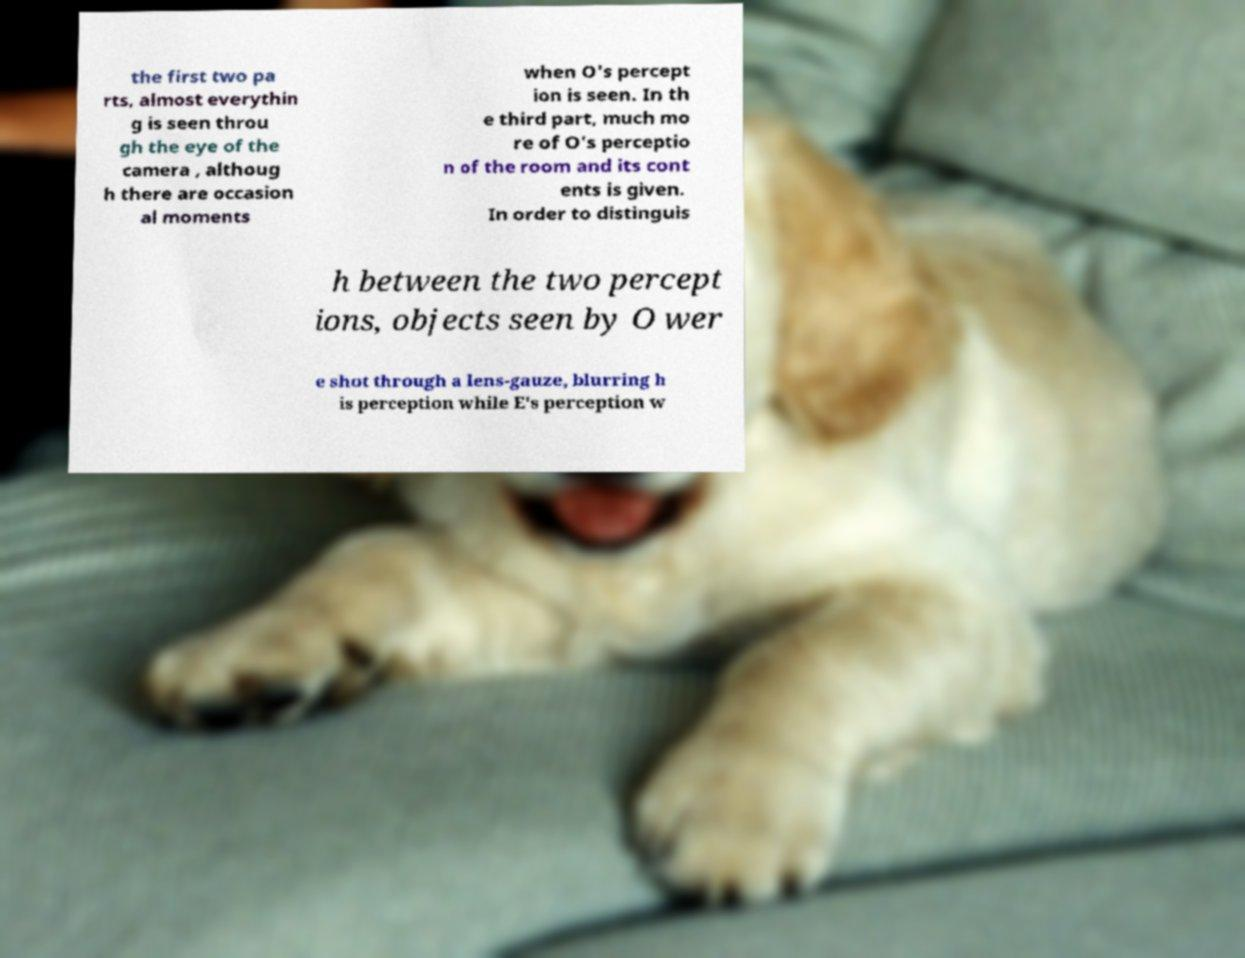Please read and relay the text visible in this image. What does it say? the first two pa rts, almost everythin g is seen throu gh the eye of the camera , althoug h there are occasion al moments when O's percept ion is seen. In th e third part, much mo re of O's perceptio n of the room and its cont ents is given. In order to distinguis h between the two percept ions, objects seen by O wer e shot through a lens-gauze, blurring h is perception while E's perception w 